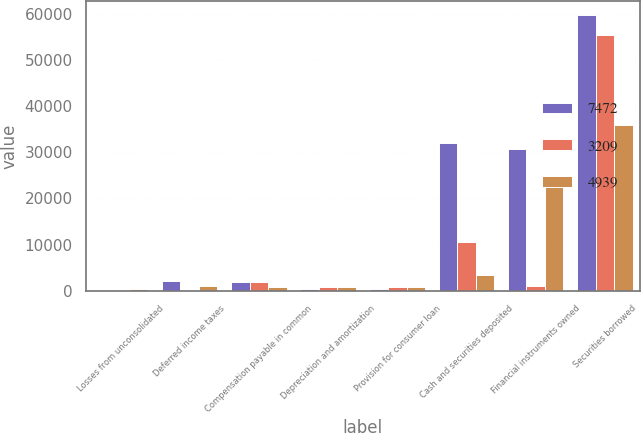Convert chart to OTSL. <chart><loc_0><loc_0><loc_500><loc_500><stacked_bar_chart><ecel><fcel>Losses from unconsolidated<fcel>Deferred income taxes<fcel>Compensation payable in common<fcel>Depreciation and amortization<fcel>Provision for consumer loan<fcel>Cash and securities deposited<fcel>Financial instruments owned<fcel>Securities borrowed<nl><fcel>7472<fcel>47<fcel>2046<fcel>1941<fcel>475<fcel>478<fcel>32040<fcel>30573<fcel>59637<nl><fcel>3209<fcel>40<fcel>111<fcel>1923<fcel>876<fcel>756<fcel>10592<fcel>999<fcel>55390<nl><fcel>4939<fcel>311<fcel>999<fcel>820<fcel>815<fcel>878<fcel>3388<fcel>24521<fcel>35892<nl></chart> 